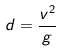<formula> <loc_0><loc_0><loc_500><loc_500>d = \frac { v ^ { 2 } } { g }</formula> 